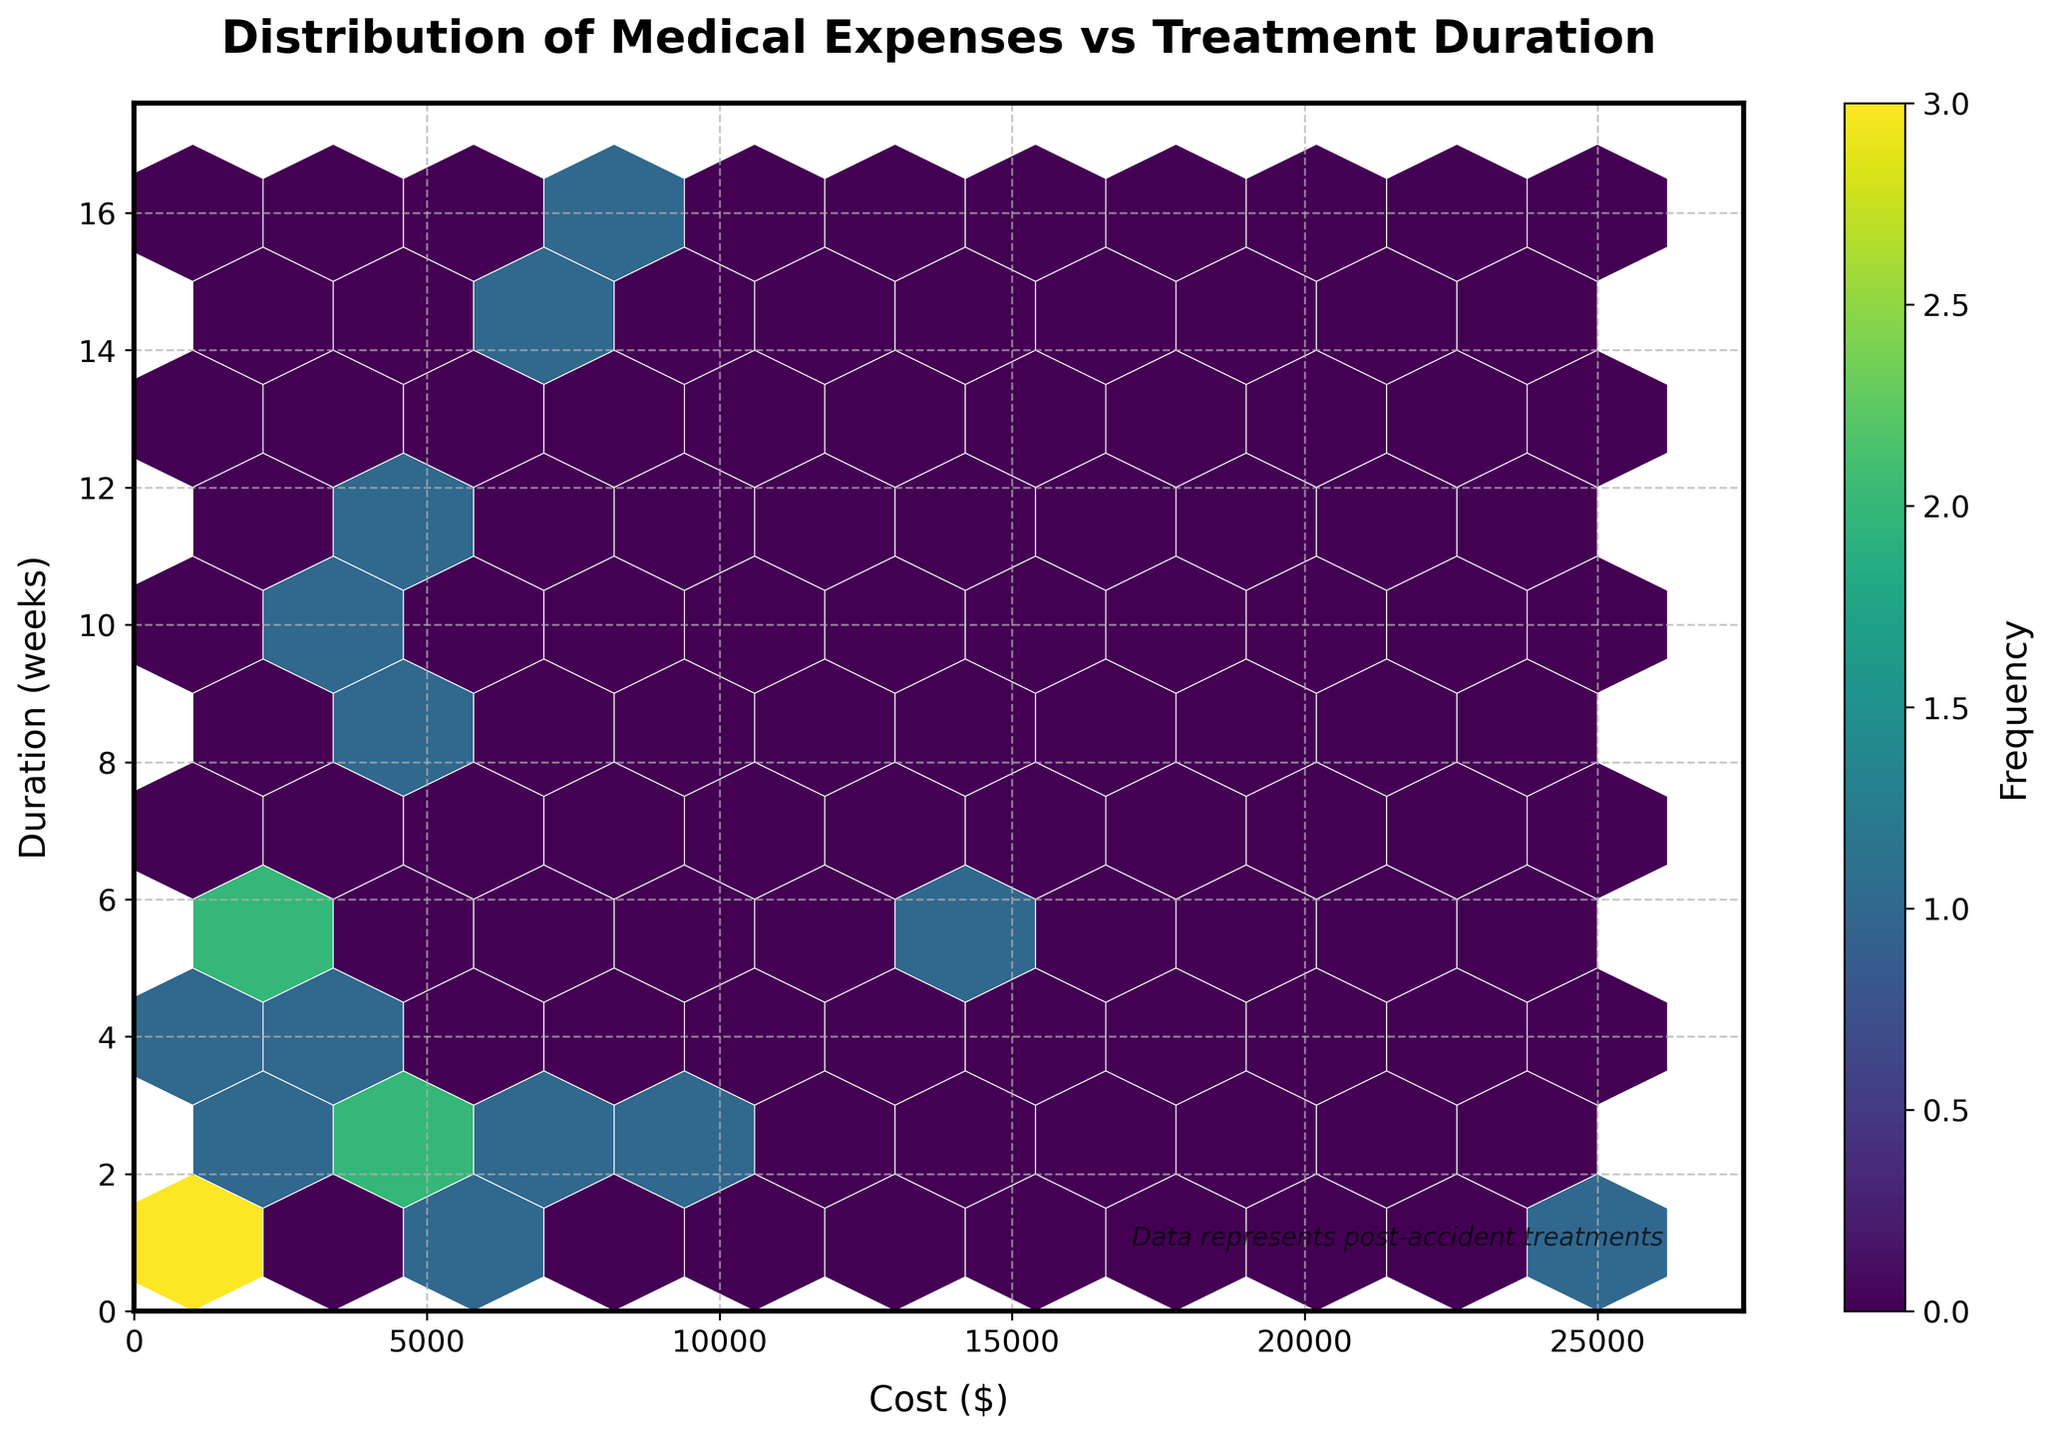What's the title of the figure? The title is displayed at the top of the figure in bold text. The title usually provides a succinct summary of what the plot is about.
Answer: "Distribution of Medical Expenses vs Treatment Duration" What are the labels for the x and y axes? The x-axis label is displayed horizontally at the bottom of the figure, and the y-axis label is displayed vertically on the left side of the figure. The labels explain what each axis represents.
Answer: Cost ($), Duration (weeks) How many hexagons does the plot contain approximately? The number of hexagons is determined by the gridsize parameter and can be estimated by counting the hexagons shown in the plot.
Answer: Approximately 100 Which treatment has the highest cost? By examining the data points on the x-axis and identifying the one with the highest value, you can determine the treatment associated with this cost. The plot indicates relative frequency but can confirm higher costs visually.
Answer: Surgery Which treatment has the shortest duration? By looking at the y-axis values and finding the data point with the smallest duration, we can identify the corresponding treatment. The hexbin plot helps visualize the distribution but checking data values could verify this.
Answer: Surgery, Imaging, Ambulance, Emergency Room, Blood Work Is there a treatment with high duration but low cost? To answer this, look for data points that extend high on the y-axis but remain low on the x-axis, indicating treatments that take longer yet do not cost much.
Answer: No How many treatments cost more than $5000? To find this, count the number of hexagons or data points right of the $5000 mark on the x-axis.
Answer: 8 Which treatment categories appear most frequently? The color intensity of the hexagons represents frequency. The plot is designed to visually highlight more frequent occurrences. Look for the hexagons with darker shades.
Answer: Physical Therapy, Pain Management, Occupational Therapy What is the overall relationship between cost and duration? By observing the general trend and spread of hexagons, one can infer the correlation between the two variables. The spread and concentration of colors indicate this relationship.
Answer: Generally, there is no strong correlation Which treatment types have both high cost and high duration? Find the data points that are positioned towards the upper right corner of the plot, which indicates both high cost and long duration.
Answer: Rehabilitation, Home Care 